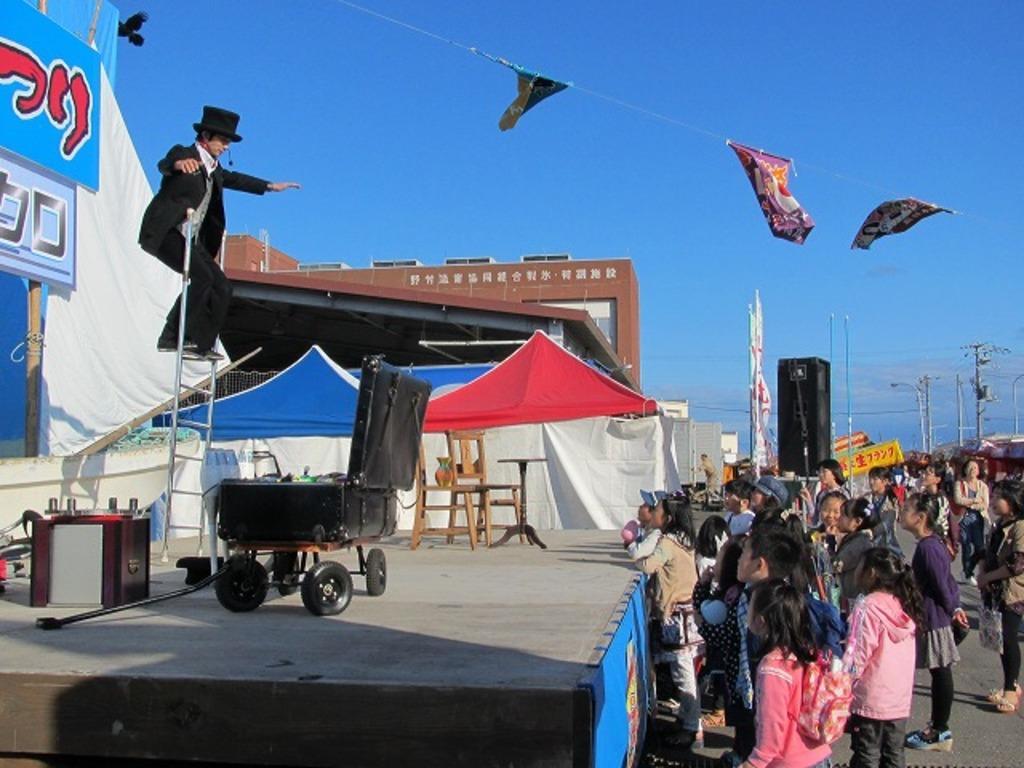How would you summarize this image in a sentence or two? In this image I can see a stage in which I can see a magician standing on a ladder. I can see a suitcase kept on a table with wheels in front of him. I can see a wooden table, chairs, a vase, some metal and electronic devices on the stage. I can see tents, some buildings and poles in the center of the image. I can see some people and some kids standing facing towards the left on the road. I can see some flags hanging on a rope in the center of the image. 